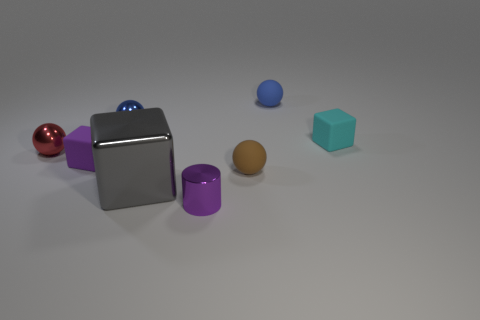There is a cylinder that is the same size as the brown rubber sphere; what is its color?
Keep it short and to the point. Purple. How many objects are either blocks that are left of the small cyan block or small rubber objects?
Offer a very short reply. 5. There is a thing that is the same color as the cylinder; what is its shape?
Keep it short and to the point. Cube. What is the material of the tiny object that is on the left side of the rubber block to the left of the cyan block?
Offer a terse response. Metal. Are there any tiny balls made of the same material as the large gray block?
Offer a very short reply. Yes. Are there any blue matte balls that are in front of the brown object that is in front of the purple matte thing?
Provide a succinct answer. No. What is the material of the small block that is on the left side of the gray object?
Your answer should be compact. Rubber. Is the brown thing the same shape as the small blue metal thing?
Provide a short and direct response. Yes. There is a tiny cube that is in front of the small cube that is on the right side of the purple thing that is left of the small metallic cylinder; what color is it?
Ensure brevity in your answer.  Purple. What number of cyan objects have the same shape as the gray shiny thing?
Ensure brevity in your answer.  1. 